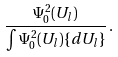Convert formula to latex. <formula><loc_0><loc_0><loc_500><loc_500>\frac { \Psi ^ { 2 } _ { 0 } ( U _ { l } ) } { \int \Psi ^ { 2 } _ { 0 } ( U _ { l } ) \{ d U _ { l } \} } \, .</formula> 